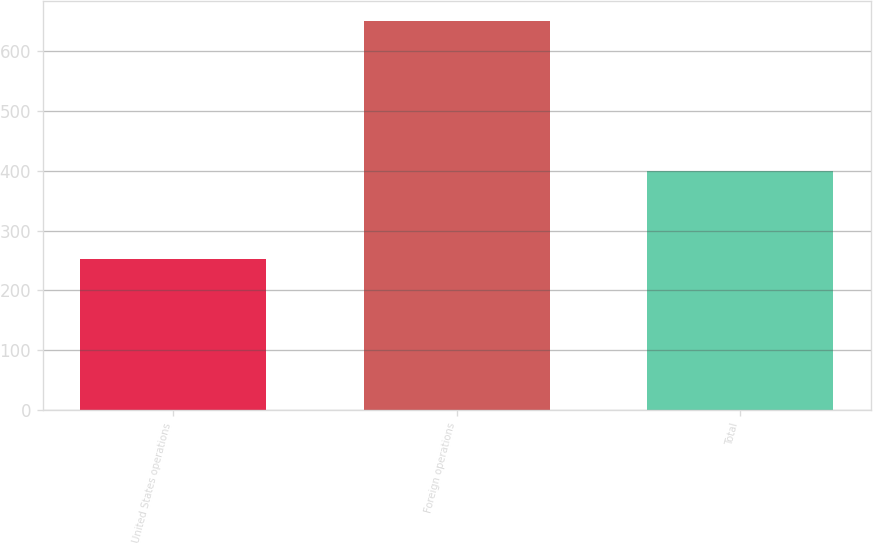Convert chart. <chart><loc_0><loc_0><loc_500><loc_500><bar_chart><fcel>United States operations<fcel>Foreign operations<fcel>Total<nl><fcel>251.8<fcel>651.4<fcel>399.6<nl></chart> 